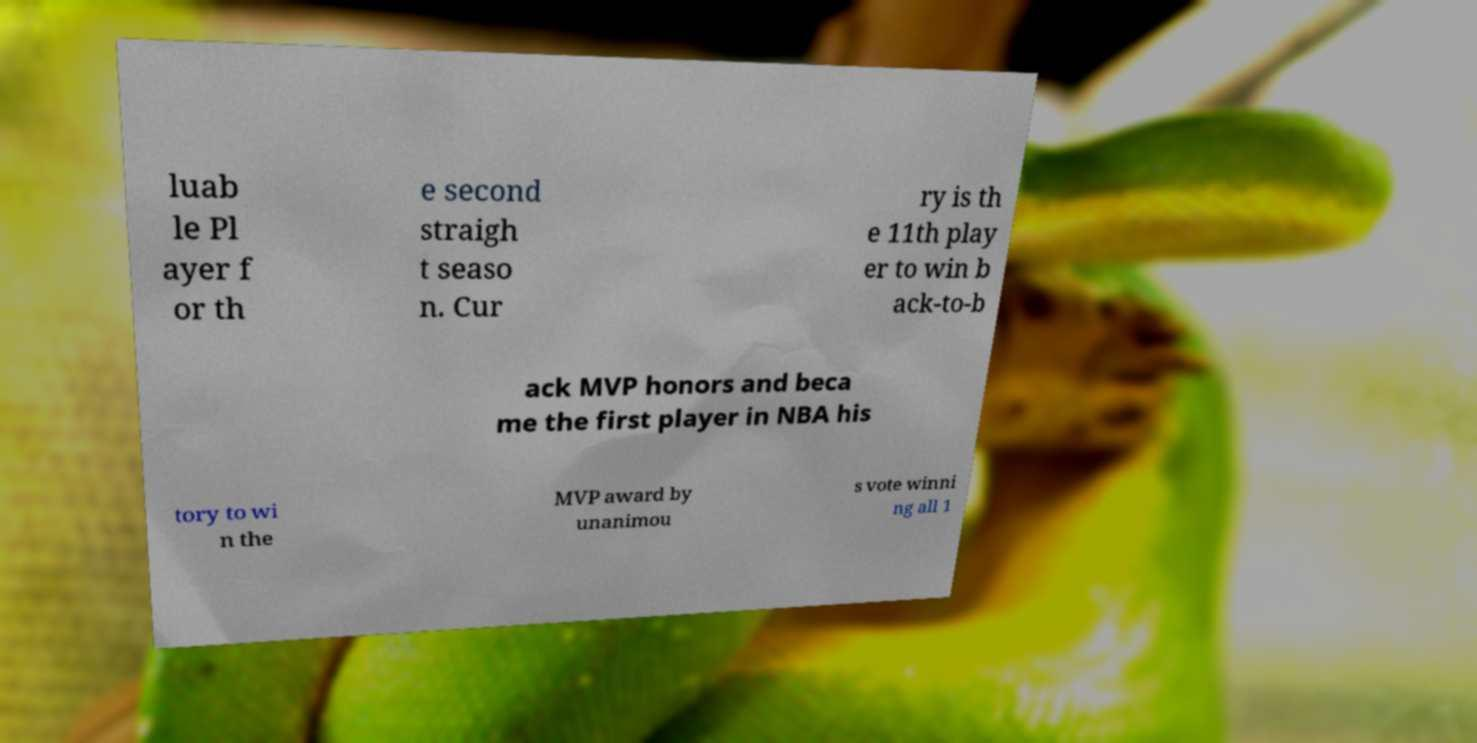There's text embedded in this image that I need extracted. Can you transcribe it verbatim? luab le Pl ayer f or th e second straigh t seaso n. Cur ry is th e 11th play er to win b ack-to-b ack MVP honors and beca me the first player in NBA his tory to wi n the MVP award by unanimou s vote winni ng all 1 